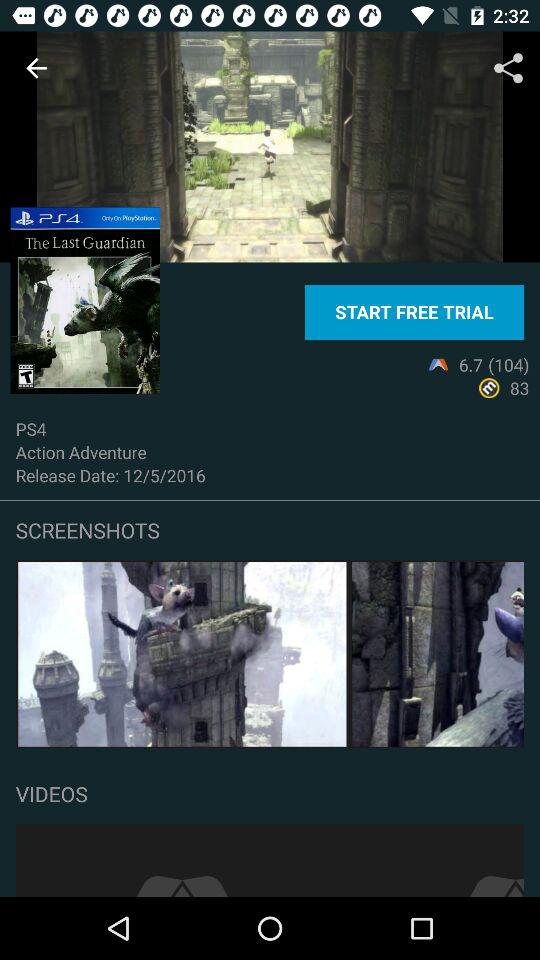Is the trial free or paid? The trial is free. 